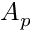<formula> <loc_0><loc_0><loc_500><loc_500>A _ { p }</formula> 